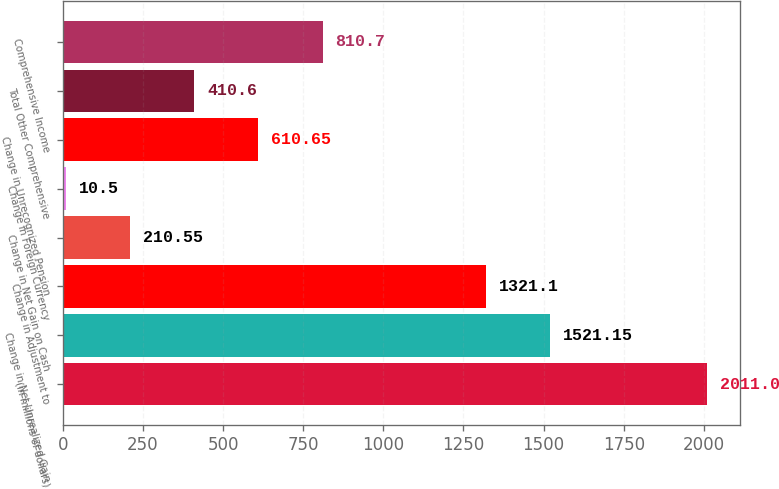Convert chart to OTSL. <chart><loc_0><loc_0><loc_500><loc_500><bar_chart><fcel>(in millions of dollars)<fcel>Change in Net Unrealized Gain<fcel>Change in Adjustment to<fcel>Change in Net Gain on Cash<fcel>Change in Foreign Currency<fcel>Change in Unrecognized Pension<fcel>Total Other Comprehensive<fcel>Comprehensive Income<nl><fcel>2011<fcel>1521.15<fcel>1321.1<fcel>210.55<fcel>10.5<fcel>610.65<fcel>410.6<fcel>810.7<nl></chart> 